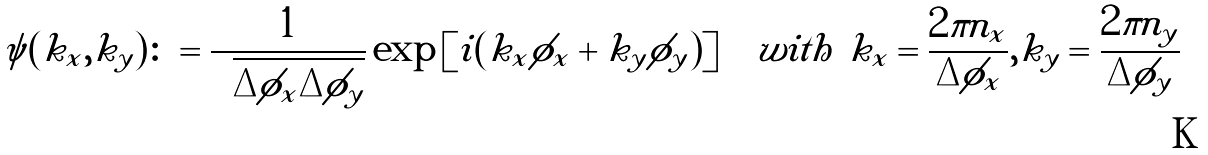Convert formula to latex. <formula><loc_0><loc_0><loc_500><loc_500>\psi ( k _ { x } , k _ { y } ) \colon = \frac { 1 } { \sqrt { \Delta \phi _ { x } \Delta \phi _ { y } } } \exp \left [ i ( k _ { x } \phi _ { x } + k _ { y } \phi _ { y } ) \right ] \quad w i t h \ k _ { x } = \frac { 2 \pi n _ { x } } { \Delta \phi _ { x } } , k _ { y } = \frac { 2 \pi n _ { y } } { \Delta \phi _ { y } }</formula> 